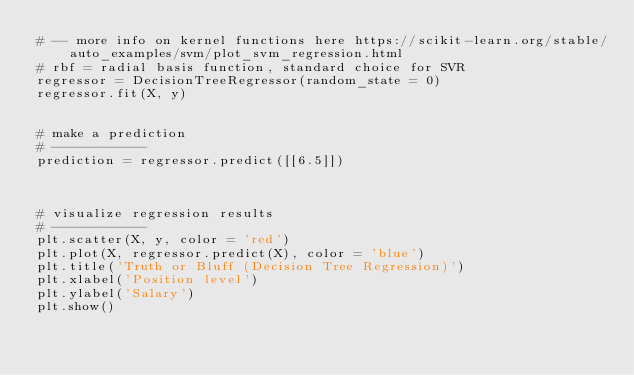<code> <loc_0><loc_0><loc_500><loc_500><_Python_># -- more info on kernel functions here https://scikit-learn.org/stable/auto_examples/svm/plot_svm_regression.html
# rbf = radial basis function, standard choice for SVR
regressor = DecisionTreeRegressor(random_state = 0)
regressor.fit(X, y)


# make a prediction
# ------------
prediction = regressor.predict([[6.5]])



# visualize regression results
# ------------
plt.scatter(X, y, color = 'red')
plt.plot(X, regressor.predict(X), color = 'blue')
plt.title('Truth or Bluff (Decision Tree Regression)')
plt.xlabel('Position level')
plt.ylabel('Salary')
plt.show()





</code> 